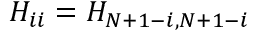<formula> <loc_0><loc_0><loc_500><loc_500>H _ { i i } = H _ { N + 1 - i , N + 1 - i }</formula> 